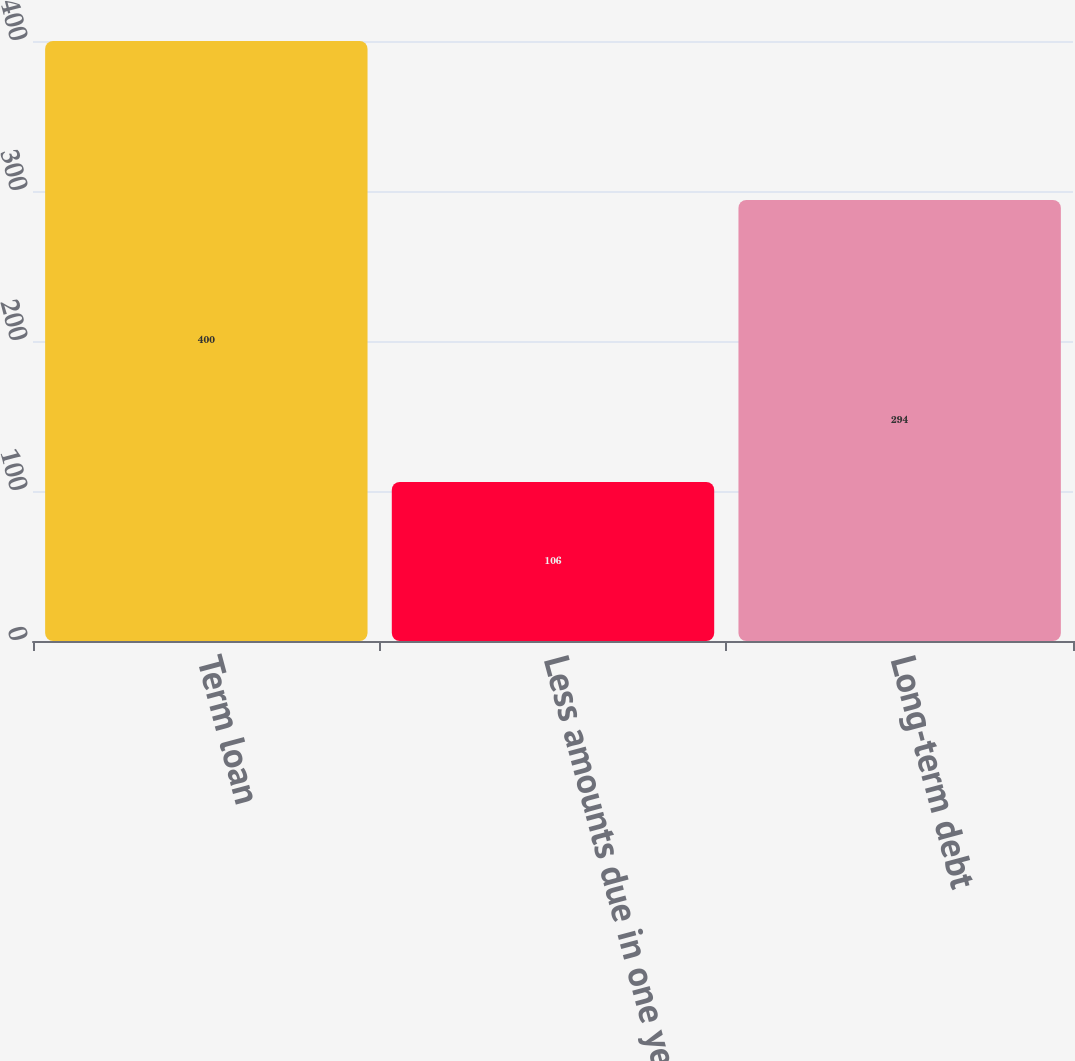<chart> <loc_0><loc_0><loc_500><loc_500><bar_chart><fcel>Term loan<fcel>Less amounts due in one year<fcel>Long-term debt<nl><fcel>400<fcel>106<fcel>294<nl></chart> 